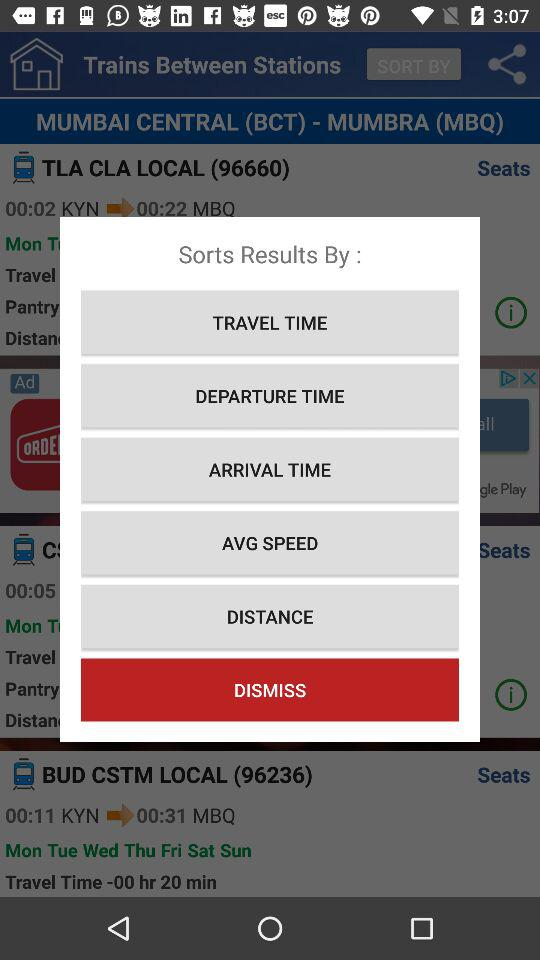Which option is selected?
When the provided information is insufficient, respond with <no answer>. <no answer> 